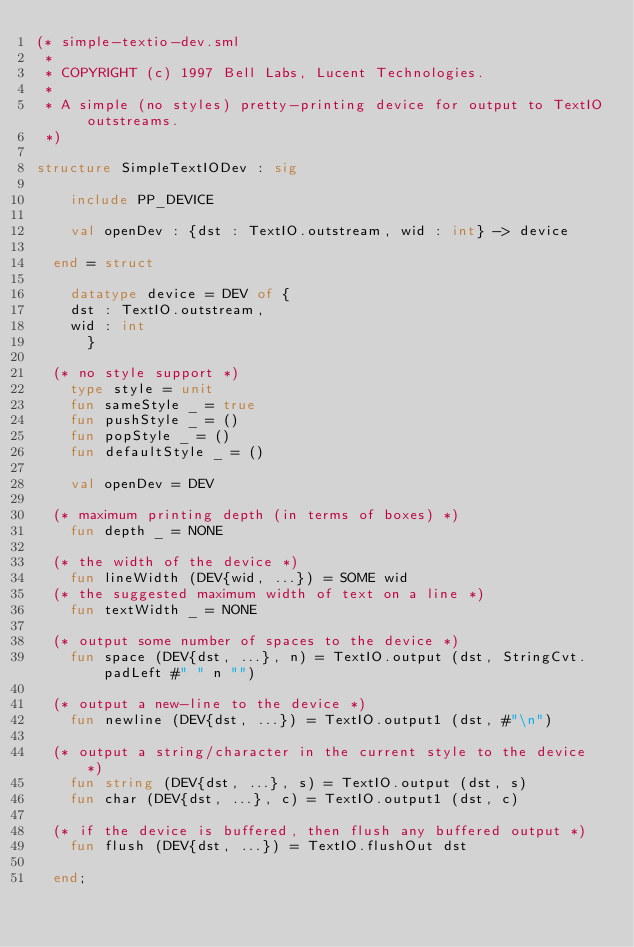<code> <loc_0><loc_0><loc_500><loc_500><_SML_>(* simple-textio-dev.sml
 *
 * COPYRIGHT (c) 1997 Bell Labs, Lucent Technologies.
 *
 * A simple (no styles) pretty-printing device for output to TextIO outstreams.
 *)

structure SimpleTextIODev : sig

    include PP_DEVICE

    val openDev : {dst : TextIO.outstream, wid : int} -> device

  end = struct

    datatype device = DEV of {
	dst : TextIO.outstream,
	wid : int
      }

  (* no style support *)
    type style = unit
    fun sameStyle _ = true
    fun pushStyle _ = ()
    fun popStyle _ = ()
    fun defaultStyle _ = ()

    val openDev = DEV

  (* maximum printing depth (in terms of boxes) *)
    fun depth _ = NONE

  (* the width of the device *)
    fun lineWidth (DEV{wid, ...}) = SOME wid
  (* the suggested maximum width of text on a line *)
    fun textWidth _ = NONE

  (* output some number of spaces to the device *)
    fun space (DEV{dst, ...}, n) = TextIO.output (dst, StringCvt.padLeft #" " n "")

  (* output a new-line to the device *)
    fun newline (DEV{dst, ...}) = TextIO.output1 (dst, #"\n")

  (* output a string/character in the current style to the device *)
    fun string (DEV{dst, ...}, s) = TextIO.output (dst, s)
    fun char (DEV{dst, ...}, c) = TextIO.output1 (dst, c)

  (* if the device is buffered, then flush any buffered output *)
    fun flush (DEV{dst, ...}) = TextIO.flushOut dst

  end;

</code> 